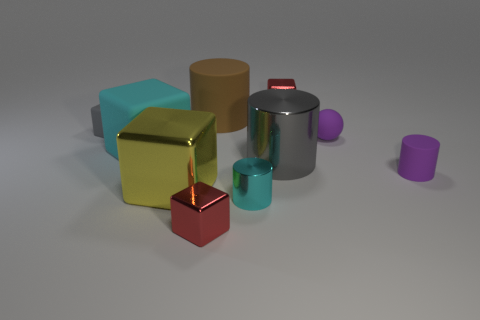There is a purple thing that is left of the purple cylinder; does it have the same size as the cube right of the big brown rubber object?
Make the answer very short. Yes. Are there the same number of brown cylinders that are left of the large cyan matte object and tiny shiny things behind the brown thing?
Offer a very short reply. No. Does the cyan rubber cube have the same size as the rubber cylinder that is behind the purple ball?
Offer a very short reply. Yes. There is a cyan thing left of the big cylinder behind the big cyan block; what is its material?
Your response must be concise. Rubber. Is the number of big metal cylinders left of the yellow shiny thing the same as the number of large gray rubber objects?
Make the answer very short. Yes. What size is the cylinder that is behind the purple cylinder and on the right side of the large matte cylinder?
Offer a terse response. Large. There is a cube in front of the large metallic object on the left side of the cyan shiny thing; what is its color?
Your answer should be compact. Red. What number of red things are metallic cylinders or cubes?
Your answer should be compact. 2. What color is the block that is both to the right of the cyan matte thing and behind the big cyan block?
Give a very brief answer. Red. How many big objects are brown rubber things or blue metal blocks?
Your answer should be compact. 1. 